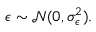<formula> <loc_0><loc_0><loc_500><loc_500>\epsilon \sim \mathcal { N } ( 0 , \sigma _ { \epsilon } ^ { 2 } ) .</formula> 